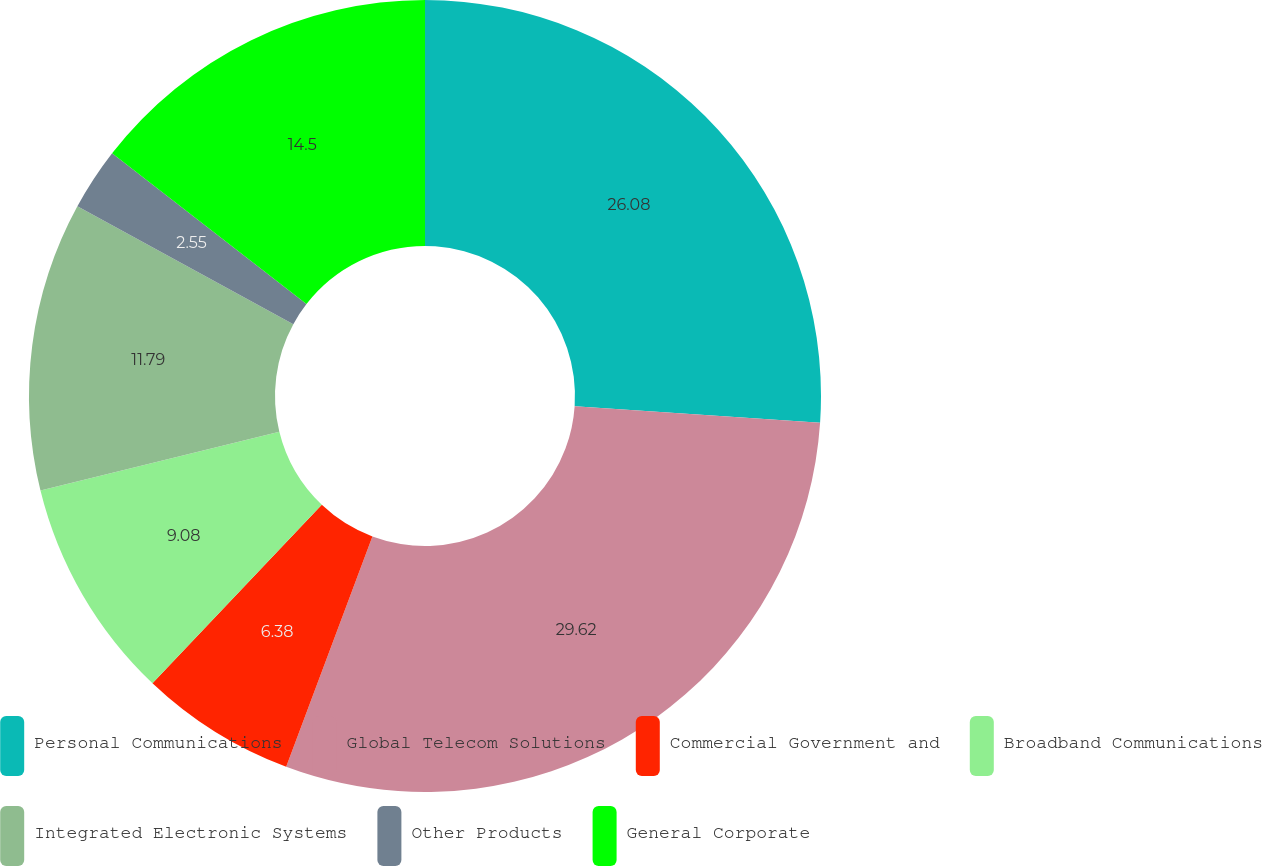<chart> <loc_0><loc_0><loc_500><loc_500><pie_chart><fcel>Personal Communications<fcel>Global Telecom Solutions<fcel>Commercial Government and<fcel>Broadband Communications<fcel>Integrated Electronic Systems<fcel>Other Products<fcel>General Corporate<nl><fcel>26.08%<fcel>29.62%<fcel>6.38%<fcel>9.08%<fcel>11.79%<fcel>2.55%<fcel>14.5%<nl></chart> 